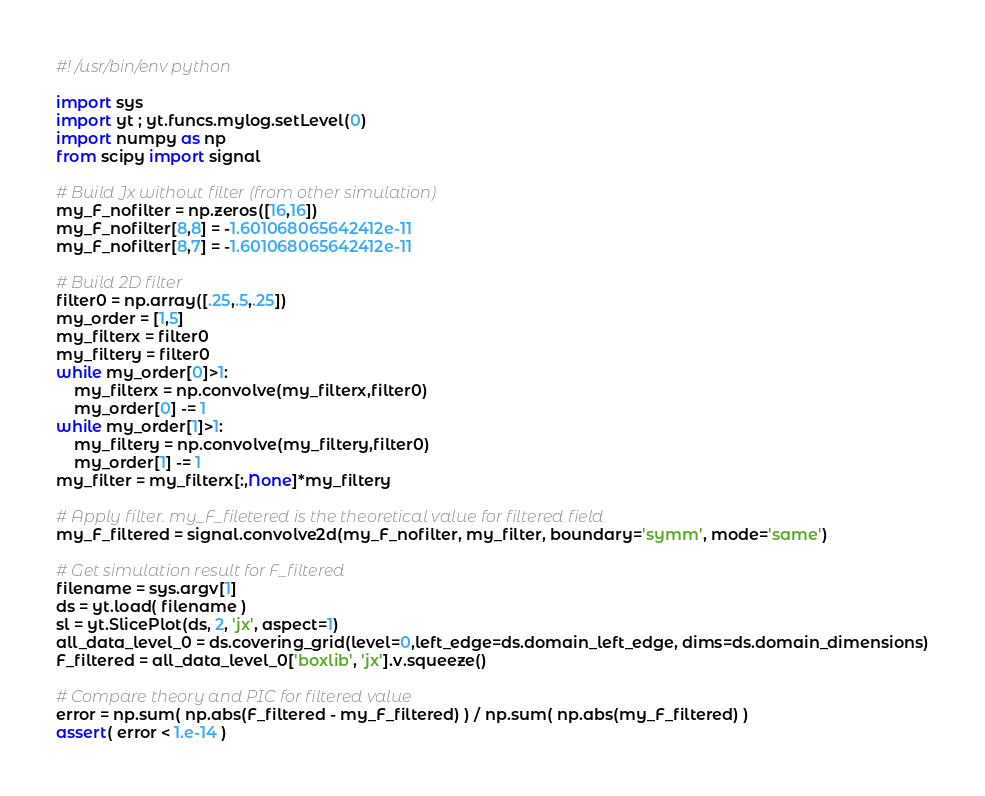Convert code to text. <code><loc_0><loc_0><loc_500><loc_500><_Python_>#! /usr/bin/env python

import sys
import yt ; yt.funcs.mylog.setLevel(0)
import numpy as np
from scipy import signal

# Build Jx without filter (from other simulation)
my_F_nofilter = np.zeros([16,16])
my_F_nofilter[8,8] = -1.601068065642412e-11
my_F_nofilter[8,7] = -1.601068065642412e-11

# Build 2D filter
filter0 = np.array([.25,.5,.25])
my_order = [1,5]
my_filterx = filter0
my_filtery = filter0
while my_order[0]>1:
    my_filterx = np.convolve(my_filterx,filter0)
    my_order[0] -= 1
while my_order[1]>1:
    my_filtery = np.convolve(my_filtery,filter0)
    my_order[1] -= 1
my_filter = my_filterx[:,None]*my_filtery

# Apply filter. my_F_filetered is the theoretical value for filtered field
my_F_filtered = signal.convolve2d(my_F_nofilter, my_filter, boundary='symm', mode='same')

# Get simulation result for F_filtered
filename = sys.argv[1]
ds = yt.load( filename )
sl = yt.SlicePlot(ds, 2, 'jx', aspect=1)
all_data_level_0 = ds.covering_grid(level=0,left_edge=ds.domain_left_edge, dims=ds.domain_dimensions)
F_filtered = all_data_level_0['boxlib', 'jx'].v.squeeze()

# Compare theory and PIC for filtered value
error = np.sum( np.abs(F_filtered - my_F_filtered) ) / np.sum( np.abs(my_F_filtered) )
assert( error < 1.e-14 )
</code> 